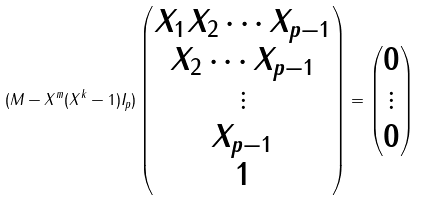Convert formula to latex. <formula><loc_0><loc_0><loc_500><loc_500>( M - X ^ { m } ( X ^ { k } - 1 ) I _ { p } ) \begin{pmatrix} X _ { 1 } X _ { 2 } \cdots X _ { p - 1 } \\ X _ { 2 } \cdots X _ { p - 1 } \\ \vdots \\ X _ { p - 1 } \\ 1 \end{pmatrix} = \begin{pmatrix} 0 \\ \vdots \\ 0 \end{pmatrix}</formula> 